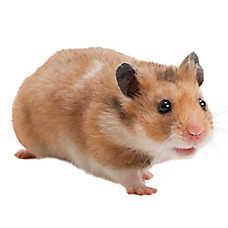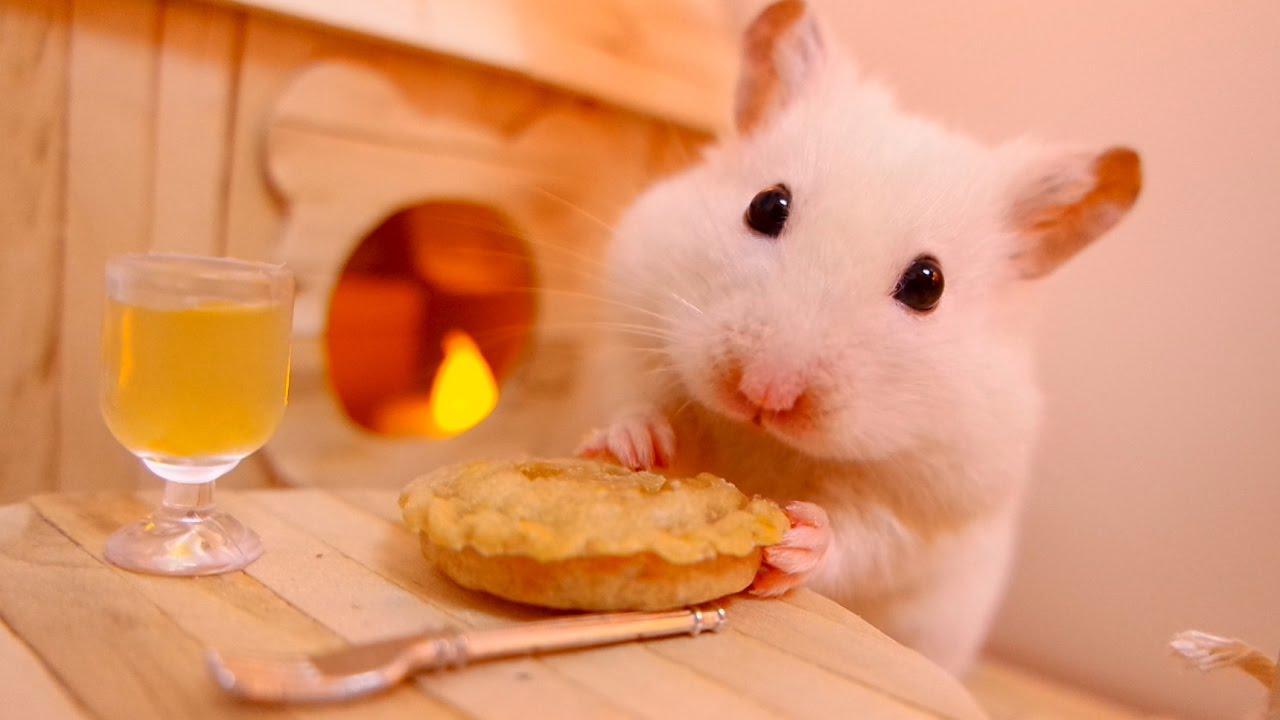The first image is the image on the left, the second image is the image on the right. For the images displayed, is the sentence "One of the images has a plain white background." factually correct? Answer yes or no. Yes. 